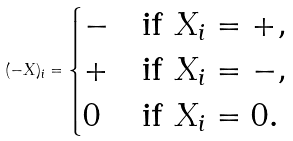Convert formula to latex. <formula><loc_0><loc_0><loc_500><loc_500>( - X ) _ { i } = \begin{cases} - & \text {if $X_{i} = +$} , \\ + & \text {if $X_{i} = -$} , \\ 0 & \text {if $X_{i} = 0$} . \end{cases}</formula> 